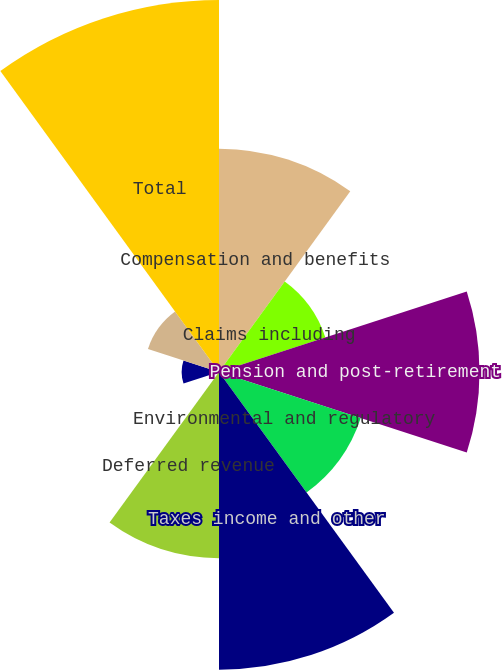Convert chart. <chart><loc_0><loc_0><loc_500><loc_500><pie_chart><fcel>Compensation and benefits<fcel>Claims including<fcel>Pension and post-retirement<fcel>Environmental and regulatory<fcel>Taxes income and other<fcel>Deferred revenue<fcel>Sales and product allowances<fcel>Warranty<fcel>Other<fcel>Total<nl><fcel>13.04%<fcel>6.53%<fcel>15.21%<fcel>8.7%<fcel>17.38%<fcel>10.87%<fcel>0.01%<fcel>2.18%<fcel>4.36%<fcel>21.72%<nl></chart> 